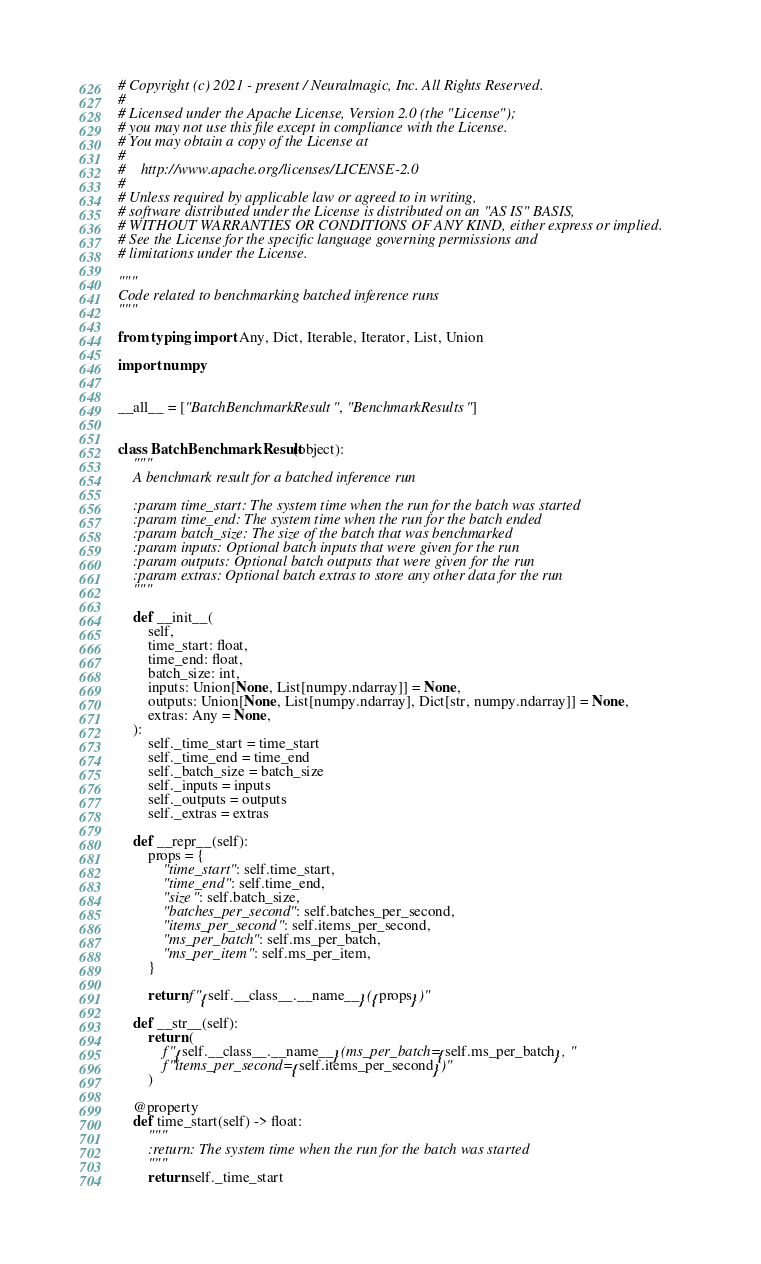<code> <loc_0><loc_0><loc_500><loc_500><_Python_># Copyright (c) 2021 - present / Neuralmagic, Inc. All Rights Reserved.
#
# Licensed under the Apache License, Version 2.0 (the "License");
# you may not use this file except in compliance with the License.
# You may obtain a copy of the License at
#
#    http://www.apache.org/licenses/LICENSE-2.0
#
# Unless required by applicable law or agreed to in writing,
# software distributed under the License is distributed on an "AS IS" BASIS,
# WITHOUT WARRANTIES OR CONDITIONS OF ANY KIND, either express or implied.
# See the License for the specific language governing permissions and
# limitations under the License.

"""
Code related to benchmarking batched inference runs
"""

from typing import Any, Dict, Iterable, Iterator, List, Union

import numpy


__all__ = ["BatchBenchmarkResult", "BenchmarkResults"]


class BatchBenchmarkResult(object):
    """
    A benchmark result for a batched inference run

    :param time_start: The system time when the run for the batch was started
    :param time_end: The system time when the run for the batch ended
    :param batch_size: The size of the batch that was benchmarked
    :param inputs: Optional batch inputs that were given for the run
    :param outputs: Optional batch outputs that were given for the run
    :param extras: Optional batch extras to store any other data for the run
    """

    def __init__(
        self,
        time_start: float,
        time_end: float,
        batch_size: int,
        inputs: Union[None, List[numpy.ndarray]] = None,
        outputs: Union[None, List[numpy.ndarray], Dict[str, numpy.ndarray]] = None,
        extras: Any = None,
    ):
        self._time_start = time_start
        self._time_end = time_end
        self._batch_size = batch_size
        self._inputs = inputs
        self._outputs = outputs
        self._extras = extras

    def __repr__(self):
        props = {
            "time_start": self.time_start,
            "time_end": self.time_end,
            "size": self.batch_size,
            "batches_per_second": self.batches_per_second,
            "items_per_second": self.items_per_second,
            "ms_per_batch": self.ms_per_batch,
            "ms_per_item": self.ms_per_item,
        }

        return f"{self.__class__.__name__}({props})"

    def __str__(self):
        return (
            f"{self.__class__.__name__}(ms_per_batch={self.ms_per_batch}, "
            f"items_per_second={self.items_per_second})"
        )

    @property
    def time_start(self) -> float:
        """
        :return: The system time when the run for the batch was started
        """
        return self._time_start
</code> 